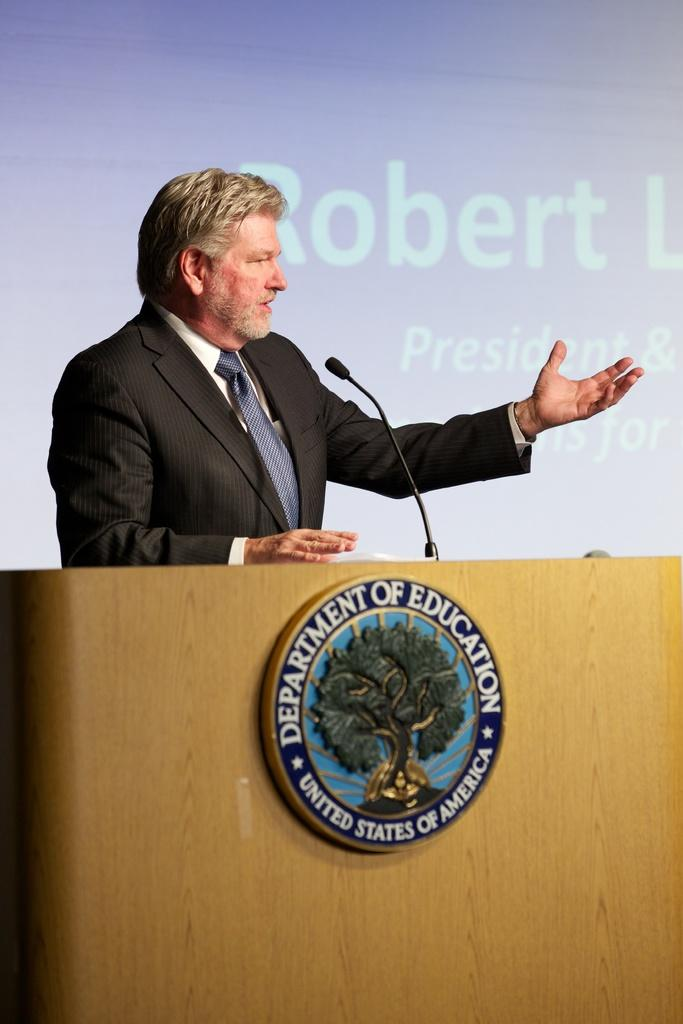Who is present in the image? There is a person in the image. What is the person wearing? The person is wearing a suit. What object can be seen in the image that is typically used for amplifying sound? There is a microphone in the image, and it is on a stand. What can be seen in the background of the image that might be used for displaying visual information? There is a projector display in the background of the image. What type of credit card does the person's aunt use to make purchases in the image? There is no mention of an aunt or a credit card in the image, so this information cannot be determined. 